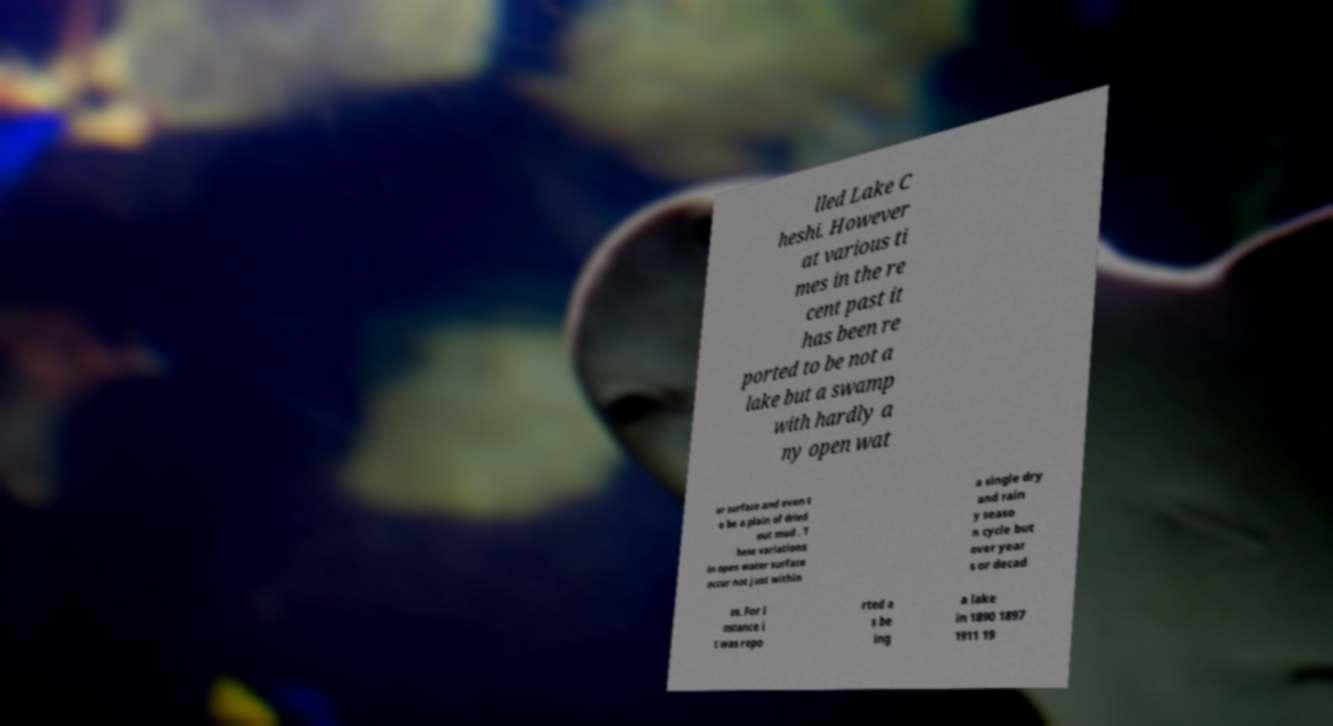Could you extract and type out the text from this image? lled Lake C heshi. However at various ti mes in the re cent past it has been re ported to be not a lake but a swamp with hardly a ny open wat er surface and even t o be a plain of dried out mud . T hese variations in open water surface occur not just within a single dry and rain y seaso n cycle but over year s or decad es. For i nstance i t was repo rted a s be ing a lake in 1890 1897 1911 19 